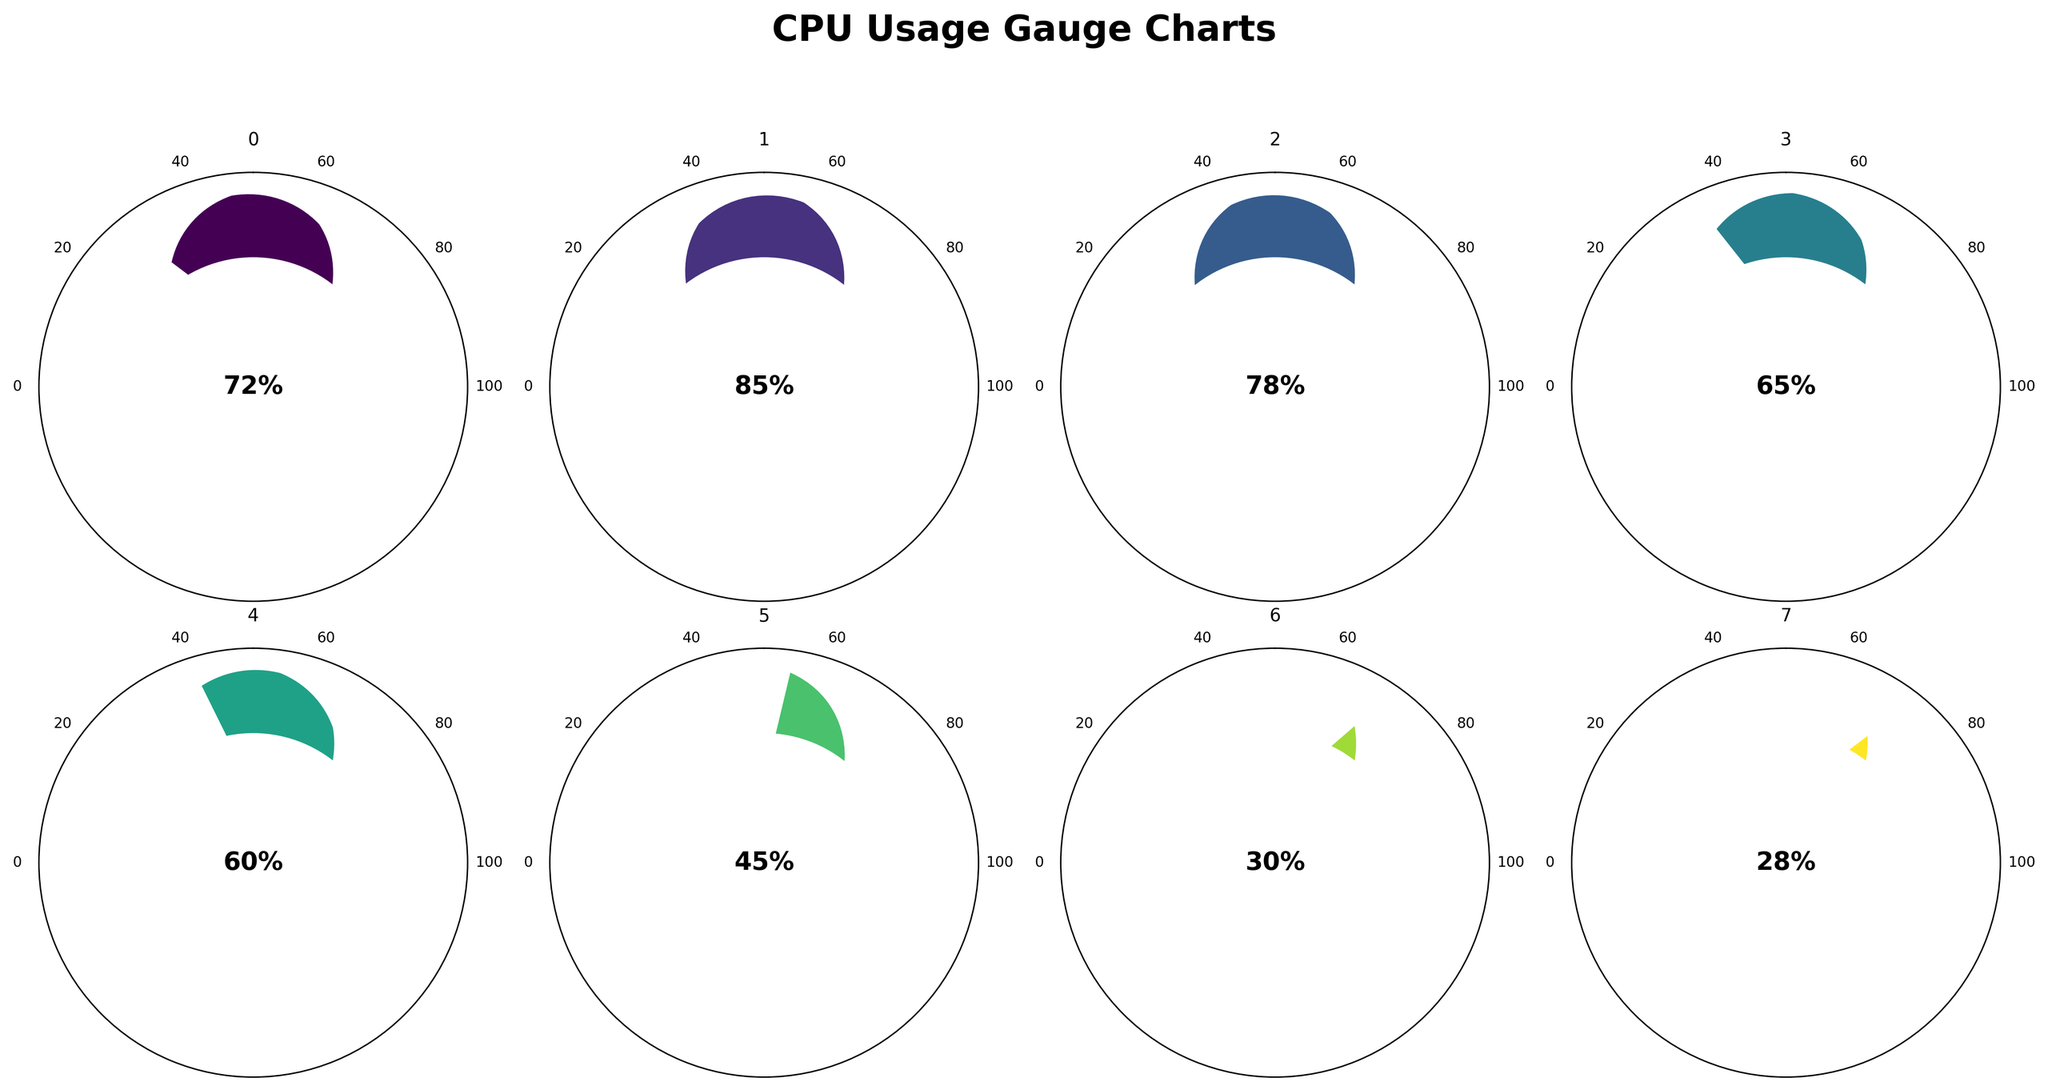What's the title of the figure? The title can be seen at the top of the figure, it is usually a descriptive summary of what the chart is about.
Answer: CPU Usage Gauge Charts How many separate gauges are shown in the figure? The entire figure is divided into smaller subplots, each representing a separate gauge. By counting these subplots, you can determine the number of gauges.
Answer: 8 Which CPU core shows the highest usage? To find this, look at the values in the center of each gauge chart and compare them. The core with the highest percentage represents the highest usage.
Answer: Core 1 What is the average usage of all CPU cores? First, extract the usage values for all the cores: Core 1 (85%), Core 2 (78%), Core 3 (65%), and Core 4 (60%). Sum these values and divide by the number of cores to find the average. (85 + 78 + 65 + 60) / 4 = 72%
Answer: 72% Which component has the lowest percentage according to the gauges? Examine the values shown on each gauge to identify the component with the smallest percentage.
Answer: System Idle Process Is the overall CPU usage higher than any of the individual core usages? Compare the overall CPU usage value to each of the core values. The overall CPU usage is 72%, which is lower than Core 1 (85%) and Core 2 (78%), but higher than Core 3 (65%) and Core 4 (60%).
Answer: Yes, higher than Core 3 and Core 4 What is the percentage difference between Core 2 and Intel Turbo Boost? Subtract the Intel Turbo Boost value from the Core 2 value: 78% - 45% = 33%.
Answer: 33% Which has a higher usage, background processes or system idle process? Compare the values associated with Background Processes and System Idle Process. Background Processes have a higher percentage.
Answer: Background Processes Does any of the gauges show a usage of exactly 50%? Check each gauge for a value that reads exactly 50%. None of the gauges show this specific value.
Answer: No If you combine the usage percentages of Core 3 and Core 4, does it surpass the overall CPU usage? Add the percentages of Core 3 and Core 4: 65% + 60% = 125%. Compare this combined value to the overall CPU usage of 72%. 125% is much higher than 72%.
Answer: Yes 